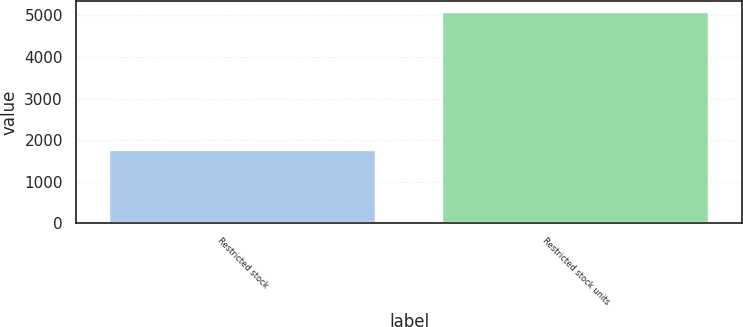<chart> <loc_0><loc_0><loc_500><loc_500><bar_chart><fcel>Restricted stock<fcel>Restricted stock units<nl><fcel>1771<fcel>5093<nl></chart> 